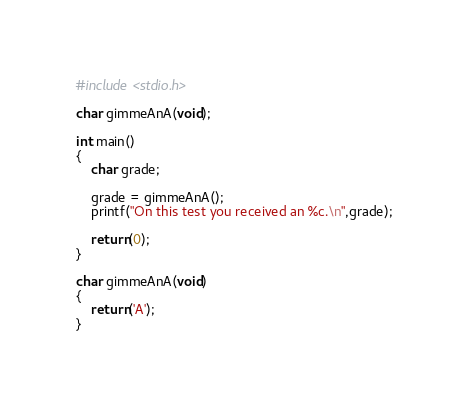<code> <loc_0><loc_0><loc_500><loc_500><_C_>#include <stdio.h>

char gimmeAnA(void);

int main()
{
	char grade;

	grade = gimmeAnA();
	printf("On this test you received an %c.\n",grade);

	return(0);
}

char gimmeAnA(void)
{
	return('A');
}

</code> 